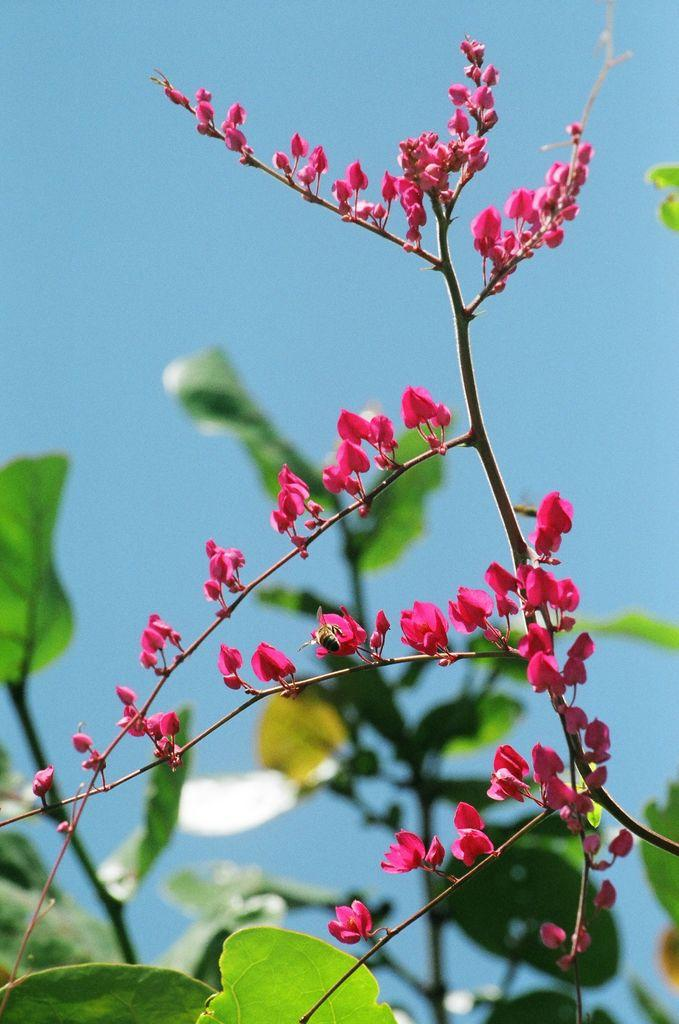What type of living organisms can be seen in the image? Plants and flowers are visible in the image. What color are the flowers in the image? The flowers in the image are pink in color. What can be seen in the background of the image? The sky is visible in the background of the image. What is the color of the sky in the image? The sky is blue in color. What type of can is visible in the image? There is no can present in the image. Can you tell me how the flowers are learning in the image? Flowers do not have the ability to learn, so this question cannot be answered. 